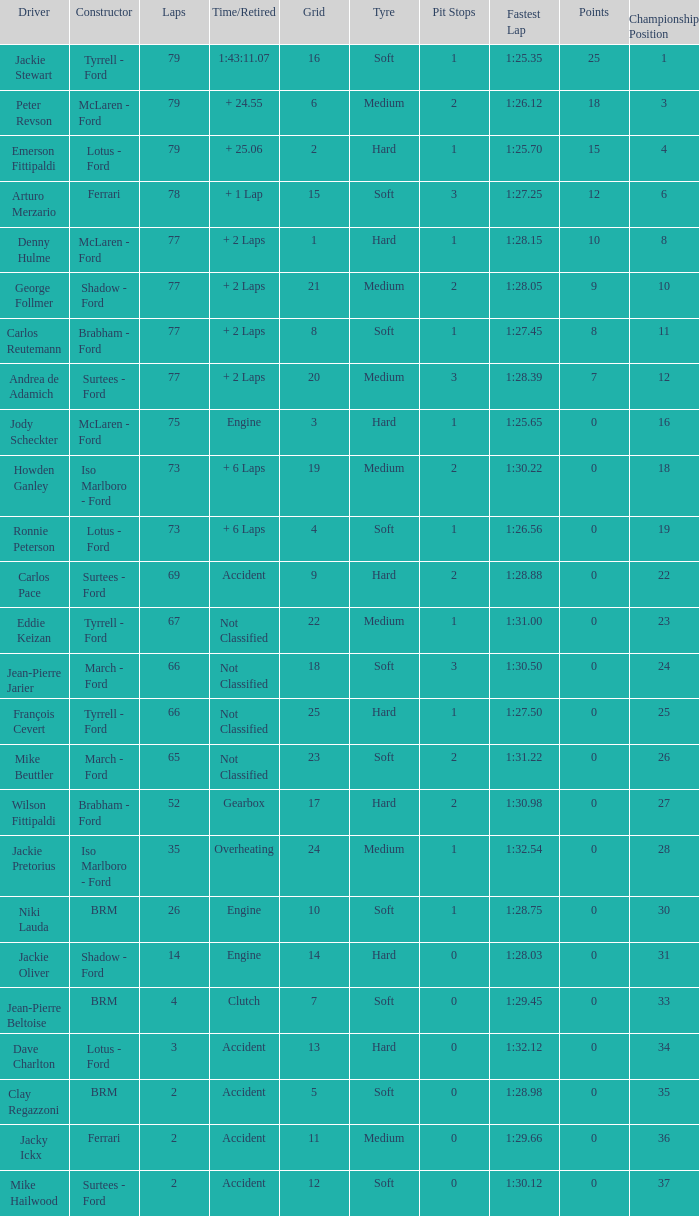What is the total grid with laps less than 2? None. 